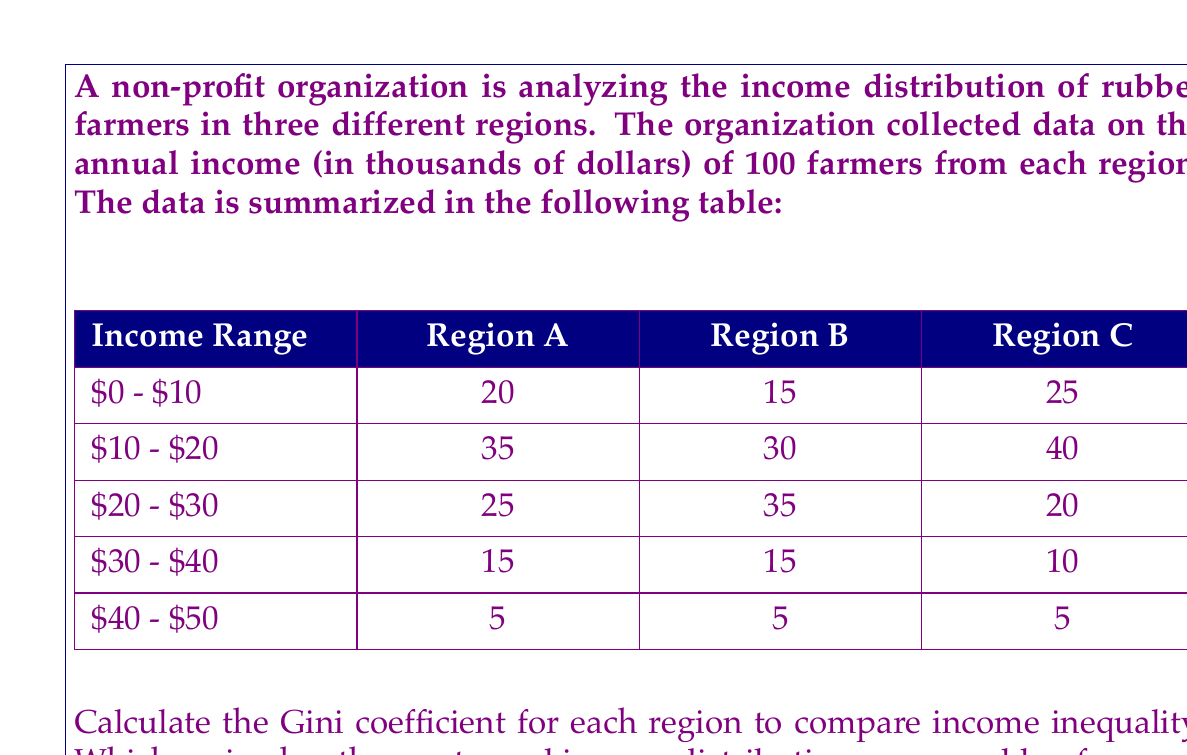Help me with this question. To solve this problem, we need to calculate the Gini coefficient for each region. The Gini coefficient is a measure of income inequality that ranges from 0 (perfect equality) to 1 (perfect inequality). We'll use the following steps:

1. Calculate the cumulative percentage of the population for each income range.
2. Calculate the cumulative percentage of income for each range.
3. Calculate the area under the Lorenz curve.
4. Calculate the Gini coefficient.

Let's go through this process for each region:

Region A:

1. Cumulative percentage of population:
   20%, 55%, 80%, 95%, 100%

2. To calculate the cumulative percentage of income, we first need to estimate the total income and the income for each range:
   Total income = (5 × 100) + (15 × 100) + (25 × 100) + (35 × 100) + (45 × 100) = 2500
   Cumulative income: 100, 550, 1300, 1850, 2500
   Cumulative percentage: 4%, 22%, 52%, 74%, 100%

3. Area under the Lorenz curve:
   $A = 0.5 \times (0.2 \times 0.04 + 0.55 \times 0.22 + 0.8 \times 0.52 + 0.95 \times 0.74 + 1 \times 1) = 0.6985$

4. Gini coefficient:
   $G_A = 1 - 2A = 1 - 2(0.6985) = 0.3030$

Region B:

Following the same process:
Cumulative population: 15%, 45%, 80%, 95%, 100%
Cumulative income percentage: 3%, 18%, 54%, 78%, 100%
Area under Lorenz curve: $A = 0.7105$
Gini coefficient: $G_B = 1 - 2(0.7105) = 0.2790$

Region C:

Cumulative population: 25%, 65%, 85%, 95%, 100%
Cumulative income percentage: 5%, 27%, 51%, 71%, 100%
Area under Lorenz curve: $A = 0.6865$
Gini coefficient: $G_C = 1 - 2(0.6865) = 0.3270$
Answer: The Gini coefficients for the three regions are:

Region A: 0.3030
Region B: 0.2790
Region C: 0.3270

Region B has the lowest Gini coefficient, indicating the most equal income distribution among rubber farmers. 